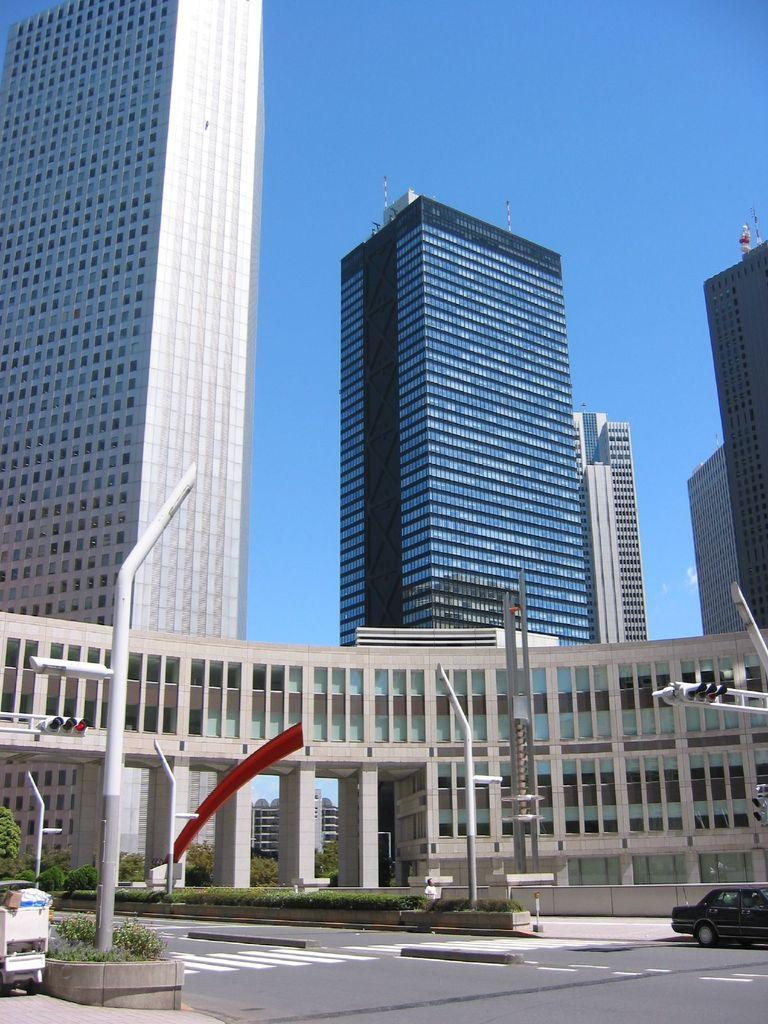What is the main feature of the image? There is a road in the image. What else can be seen along the road? There are poles and buildings visible in the image. What is visible in the background of the image? The sky is visible in the image. What type of value does the mom place on the interest of the buildings in the image? There is no reference to a mom or any values or interests in the image, so it's not possible to determine what values or interests the mom might have. 